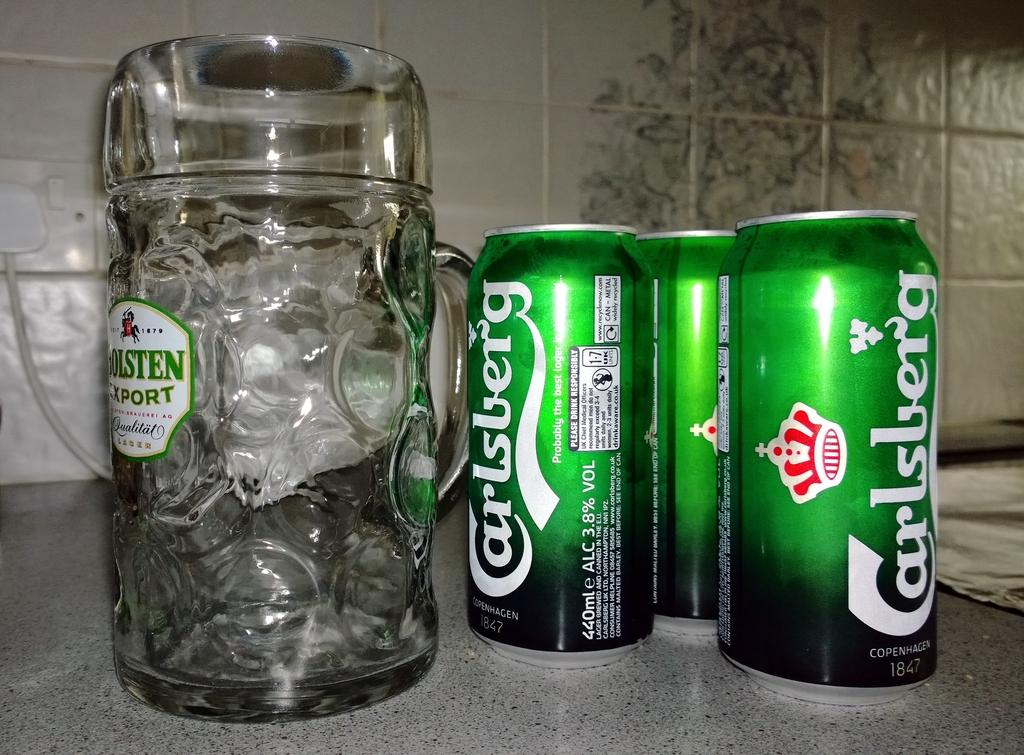<image>
Write a terse but informative summary of the picture. Some cans of Carlsberg lager in front of a glass. 